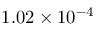<formula> <loc_0><loc_0><loc_500><loc_500>1 . 0 2 \times 1 0 ^ { - 4 }</formula> 